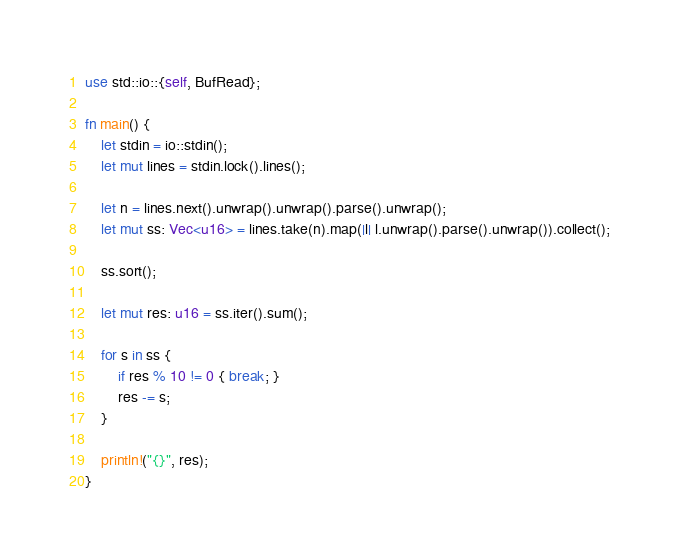Convert code to text. <code><loc_0><loc_0><loc_500><loc_500><_Rust_>use std::io::{self, BufRead};

fn main() {
    let stdin = io::stdin();
    let mut lines = stdin.lock().lines();

    let n = lines.next().unwrap().unwrap().parse().unwrap();
    let mut ss: Vec<u16> = lines.take(n).map(|l| l.unwrap().parse().unwrap()).collect();

    ss.sort();

    let mut res: u16 = ss.iter().sum();

    for s in ss {
        if res % 10 != 0 { break; }
        res -= s;
    }

    println!("{}", res);
}</code> 